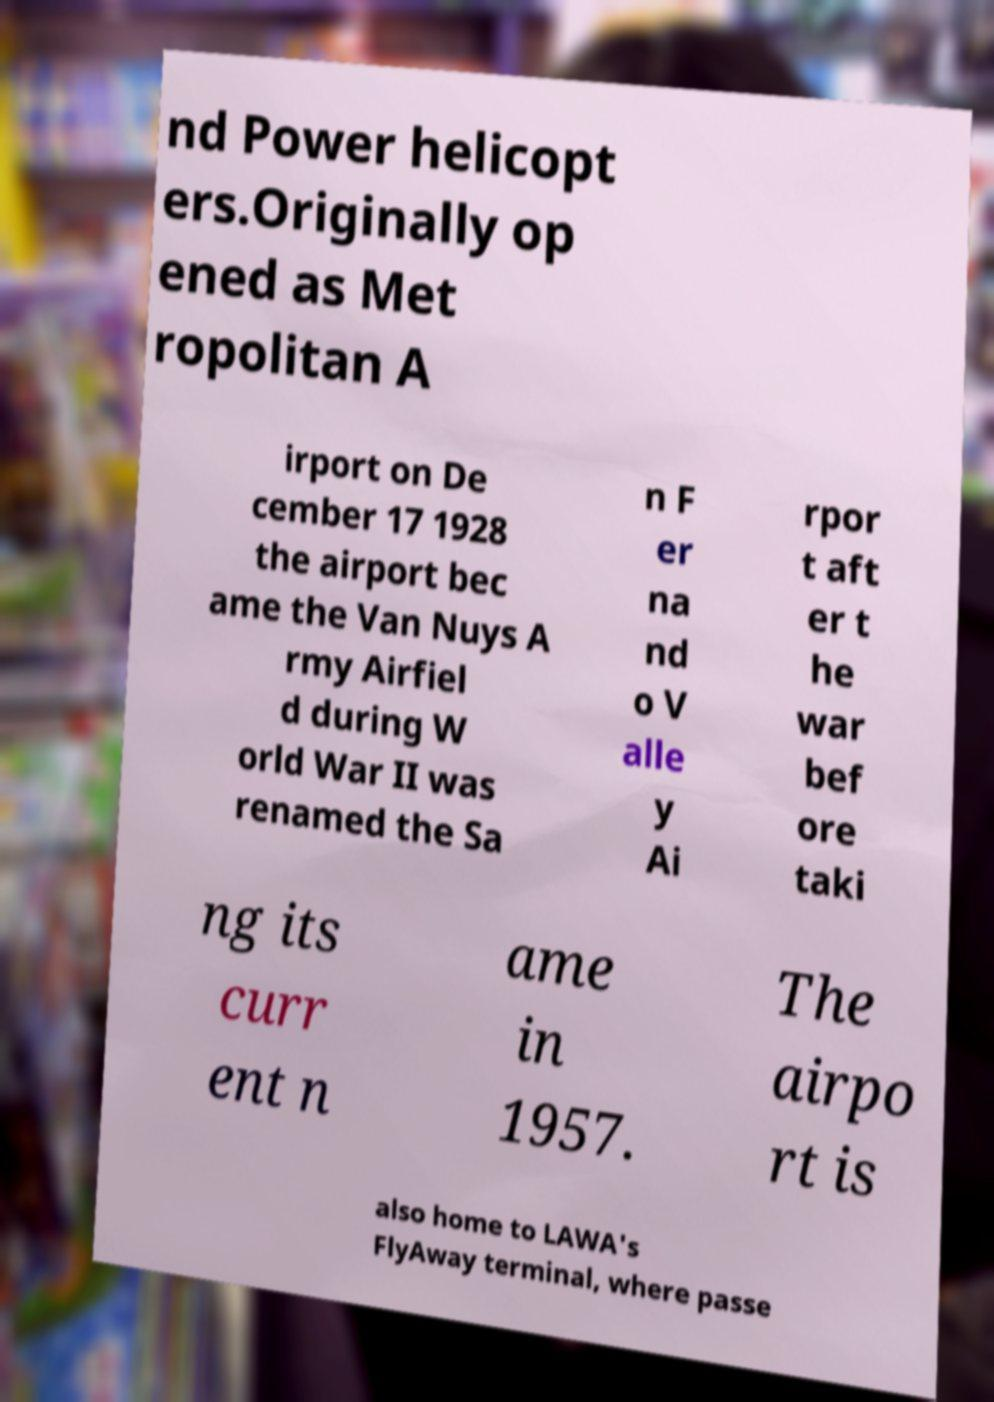I need the written content from this picture converted into text. Can you do that? nd Power helicopt ers.Originally op ened as Met ropolitan A irport on De cember 17 1928 the airport bec ame the Van Nuys A rmy Airfiel d during W orld War II was renamed the Sa n F er na nd o V alle y Ai rpor t aft er t he war bef ore taki ng its curr ent n ame in 1957. The airpo rt is also home to LAWA's FlyAway terminal, where passe 